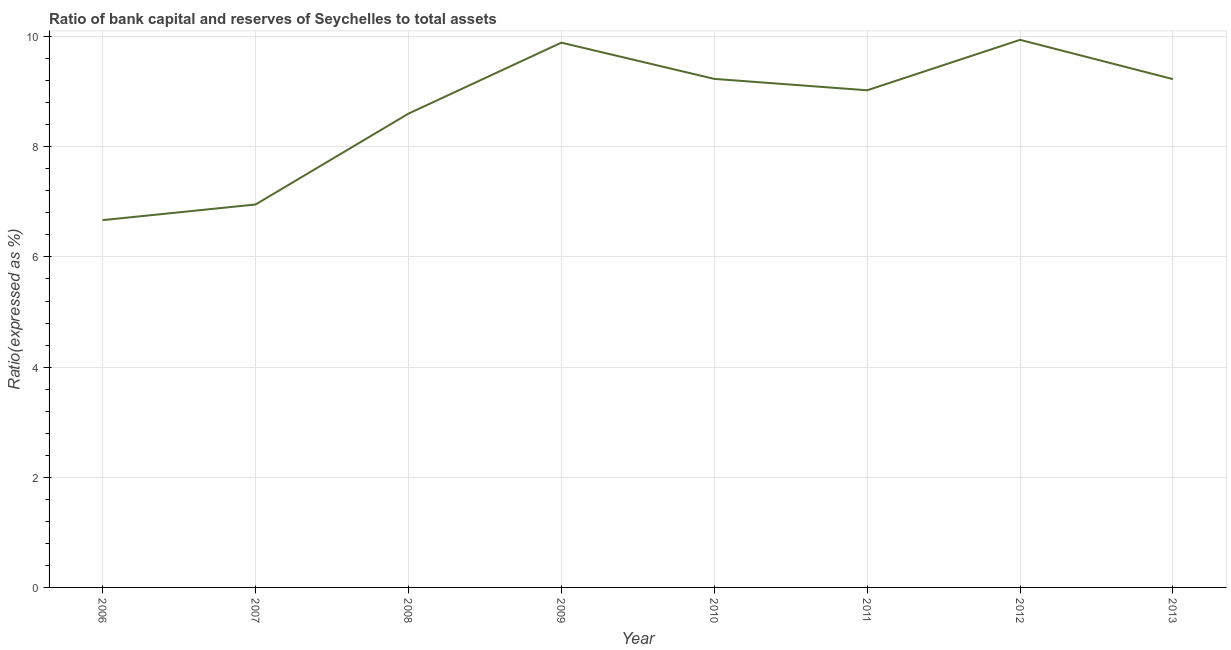What is the bank capital to assets ratio in 2012?
Your answer should be very brief. 9.94. Across all years, what is the maximum bank capital to assets ratio?
Make the answer very short. 9.94. Across all years, what is the minimum bank capital to assets ratio?
Offer a terse response. 6.67. In which year was the bank capital to assets ratio maximum?
Offer a terse response. 2012. In which year was the bank capital to assets ratio minimum?
Keep it short and to the point. 2006. What is the sum of the bank capital to assets ratio?
Provide a succinct answer. 69.54. What is the difference between the bank capital to assets ratio in 2008 and 2011?
Offer a terse response. -0.42. What is the average bank capital to assets ratio per year?
Your response must be concise. 8.69. What is the median bank capital to assets ratio?
Provide a succinct answer. 9.13. Do a majority of the years between 2006 and 2007 (inclusive) have bank capital to assets ratio greater than 5.6 %?
Your answer should be compact. Yes. What is the ratio of the bank capital to assets ratio in 2007 to that in 2008?
Offer a very short reply. 0.81. What is the difference between the highest and the second highest bank capital to assets ratio?
Your answer should be very brief. 0.05. What is the difference between the highest and the lowest bank capital to assets ratio?
Provide a succinct answer. 3.27. In how many years, is the bank capital to assets ratio greater than the average bank capital to assets ratio taken over all years?
Your answer should be compact. 5. How many lines are there?
Your answer should be compact. 1. How many years are there in the graph?
Your answer should be compact. 8. What is the difference between two consecutive major ticks on the Y-axis?
Provide a succinct answer. 2. What is the title of the graph?
Your answer should be very brief. Ratio of bank capital and reserves of Seychelles to total assets. What is the label or title of the X-axis?
Keep it short and to the point. Year. What is the label or title of the Y-axis?
Offer a terse response. Ratio(expressed as %). What is the Ratio(expressed as %) of 2006?
Your answer should be compact. 6.67. What is the Ratio(expressed as %) in 2007?
Make the answer very short. 6.95. What is the Ratio(expressed as %) in 2008?
Give a very brief answer. 8.6. What is the Ratio(expressed as %) in 2009?
Give a very brief answer. 9.89. What is the Ratio(expressed as %) of 2010?
Give a very brief answer. 9.23. What is the Ratio(expressed as %) in 2011?
Your response must be concise. 9.03. What is the Ratio(expressed as %) of 2012?
Provide a short and direct response. 9.94. What is the Ratio(expressed as %) in 2013?
Provide a succinct answer. 9.23. What is the difference between the Ratio(expressed as %) in 2006 and 2007?
Your response must be concise. -0.28. What is the difference between the Ratio(expressed as %) in 2006 and 2008?
Your answer should be very brief. -1.93. What is the difference between the Ratio(expressed as %) in 2006 and 2009?
Keep it short and to the point. -3.22. What is the difference between the Ratio(expressed as %) in 2006 and 2010?
Provide a succinct answer. -2.56. What is the difference between the Ratio(expressed as %) in 2006 and 2011?
Your answer should be compact. -2.36. What is the difference between the Ratio(expressed as %) in 2006 and 2012?
Offer a terse response. -3.27. What is the difference between the Ratio(expressed as %) in 2006 and 2013?
Offer a terse response. -2.56. What is the difference between the Ratio(expressed as %) in 2007 and 2008?
Provide a short and direct response. -1.65. What is the difference between the Ratio(expressed as %) in 2007 and 2009?
Give a very brief answer. -2.94. What is the difference between the Ratio(expressed as %) in 2007 and 2010?
Keep it short and to the point. -2.28. What is the difference between the Ratio(expressed as %) in 2007 and 2011?
Offer a terse response. -2.07. What is the difference between the Ratio(expressed as %) in 2007 and 2012?
Provide a short and direct response. -2.99. What is the difference between the Ratio(expressed as %) in 2007 and 2013?
Your answer should be very brief. -2.28. What is the difference between the Ratio(expressed as %) in 2008 and 2009?
Provide a short and direct response. -1.29. What is the difference between the Ratio(expressed as %) in 2008 and 2010?
Your response must be concise. -0.63. What is the difference between the Ratio(expressed as %) in 2008 and 2011?
Your answer should be very brief. -0.42. What is the difference between the Ratio(expressed as %) in 2008 and 2012?
Give a very brief answer. -1.34. What is the difference between the Ratio(expressed as %) in 2008 and 2013?
Make the answer very short. -0.63. What is the difference between the Ratio(expressed as %) in 2009 and 2010?
Your answer should be compact. 0.66. What is the difference between the Ratio(expressed as %) in 2009 and 2011?
Give a very brief answer. 0.86. What is the difference between the Ratio(expressed as %) in 2009 and 2012?
Offer a terse response. -0.05. What is the difference between the Ratio(expressed as %) in 2009 and 2013?
Your answer should be very brief. 0.66. What is the difference between the Ratio(expressed as %) in 2010 and 2011?
Give a very brief answer. 0.21. What is the difference between the Ratio(expressed as %) in 2010 and 2012?
Provide a succinct answer. -0.71. What is the difference between the Ratio(expressed as %) in 2010 and 2013?
Your answer should be compact. 0. What is the difference between the Ratio(expressed as %) in 2011 and 2012?
Give a very brief answer. -0.92. What is the difference between the Ratio(expressed as %) in 2011 and 2013?
Offer a very short reply. -0.2. What is the difference between the Ratio(expressed as %) in 2012 and 2013?
Provide a succinct answer. 0.71. What is the ratio of the Ratio(expressed as %) in 2006 to that in 2008?
Give a very brief answer. 0.78. What is the ratio of the Ratio(expressed as %) in 2006 to that in 2009?
Provide a succinct answer. 0.67. What is the ratio of the Ratio(expressed as %) in 2006 to that in 2010?
Your answer should be compact. 0.72. What is the ratio of the Ratio(expressed as %) in 2006 to that in 2011?
Provide a succinct answer. 0.74. What is the ratio of the Ratio(expressed as %) in 2006 to that in 2012?
Ensure brevity in your answer.  0.67. What is the ratio of the Ratio(expressed as %) in 2006 to that in 2013?
Your answer should be compact. 0.72. What is the ratio of the Ratio(expressed as %) in 2007 to that in 2008?
Your answer should be very brief. 0.81. What is the ratio of the Ratio(expressed as %) in 2007 to that in 2009?
Your answer should be very brief. 0.7. What is the ratio of the Ratio(expressed as %) in 2007 to that in 2010?
Your response must be concise. 0.75. What is the ratio of the Ratio(expressed as %) in 2007 to that in 2011?
Offer a terse response. 0.77. What is the ratio of the Ratio(expressed as %) in 2007 to that in 2012?
Provide a succinct answer. 0.7. What is the ratio of the Ratio(expressed as %) in 2007 to that in 2013?
Your response must be concise. 0.75. What is the ratio of the Ratio(expressed as %) in 2008 to that in 2009?
Offer a terse response. 0.87. What is the ratio of the Ratio(expressed as %) in 2008 to that in 2010?
Make the answer very short. 0.93. What is the ratio of the Ratio(expressed as %) in 2008 to that in 2011?
Your answer should be compact. 0.95. What is the ratio of the Ratio(expressed as %) in 2008 to that in 2012?
Your answer should be very brief. 0.86. What is the ratio of the Ratio(expressed as %) in 2008 to that in 2013?
Your answer should be very brief. 0.93. What is the ratio of the Ratio(expressed as %) in 2009 to that in 2010?
Your response must be concise. 1.07. What is the ratio of the Ratio(expressed as %) in 2009 to that in 2011?
Your answer should be compact. 1.1. What is the ratio of the Ratio(expressed as %) in 2009 to that in 2013?
Ensure brevity in your answer.  1.07. What is the ratio of the Ratio(expressed as %) in 2010 to that in 2011?
Provide a succinct answer. 1.02. What is the ratio of the Ratio(expressed as %) in 2010 to that in 2012?
Offer a very short reply. 0.93. What is the ratio of the Ratio(expressed as %) in 2011 to that in 2012?
Provide a short and direct response. 0.91. What is the ratio of the Ratio(expressed as %) in 2011 to that in 2013?
Give a very brief answer. 0.98. What is the ratio of the Ratio(expressed as %) in 2012 to that in 2013?
Provide a succinct answer. 1.08. 